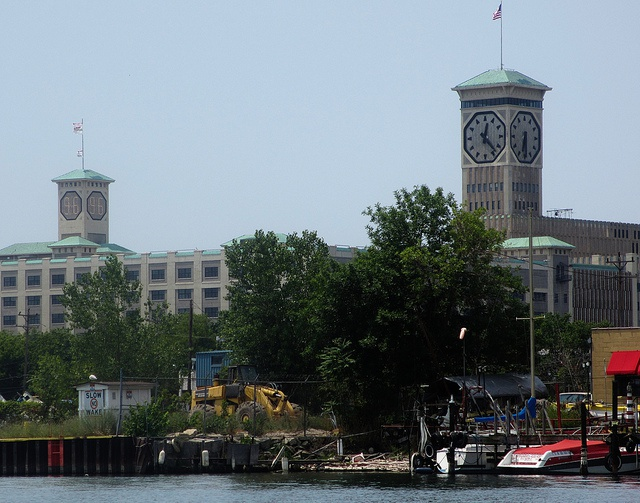Describe the objects in this image and their specific colors. I can see boat in lightblue, black, maroon, red, and white tones, boat in lightblue, black, gray, lightgray, and darkgray tones, clock in lightblue, gray, black, and darkblue tones, clock in lightblue, gray, black, and darkblue tones, and clock in lightblue, gray, and black tones in this image. 